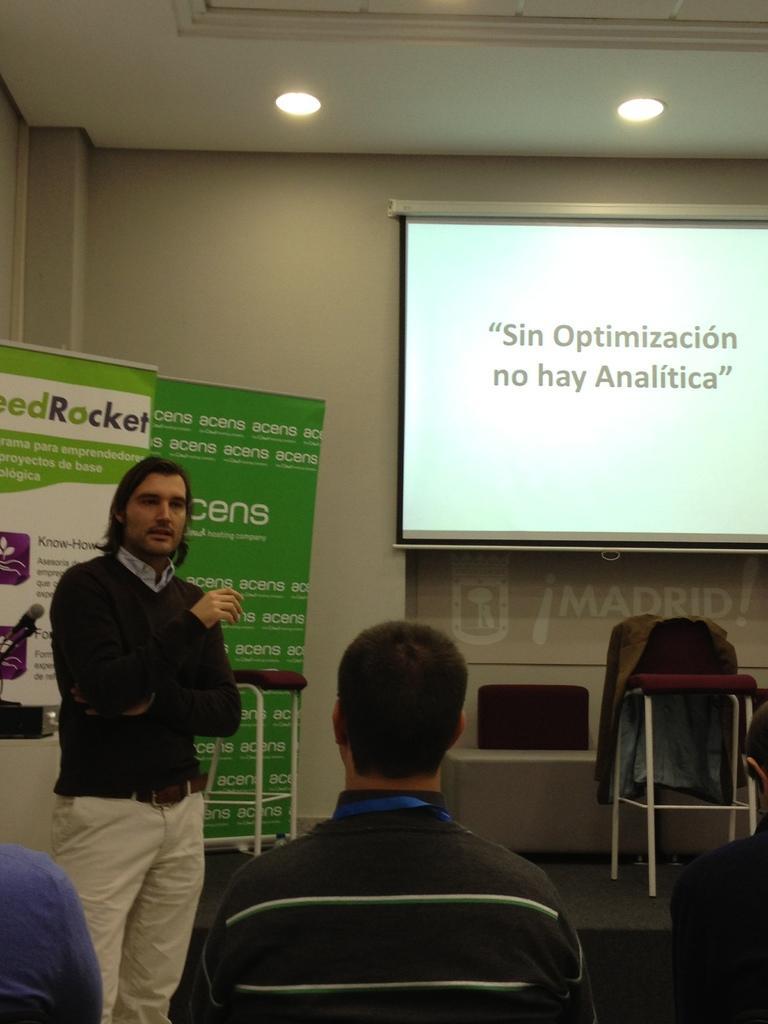In one or two sentences, can you explain what this image depicts? At the top we can see ceiling and lights. On the background we can see a wall, screen. This is a banner. Here we can see chairs. Here we can see one man standing near to the chairs. We can see few persons in front of a picture facing backwards. 